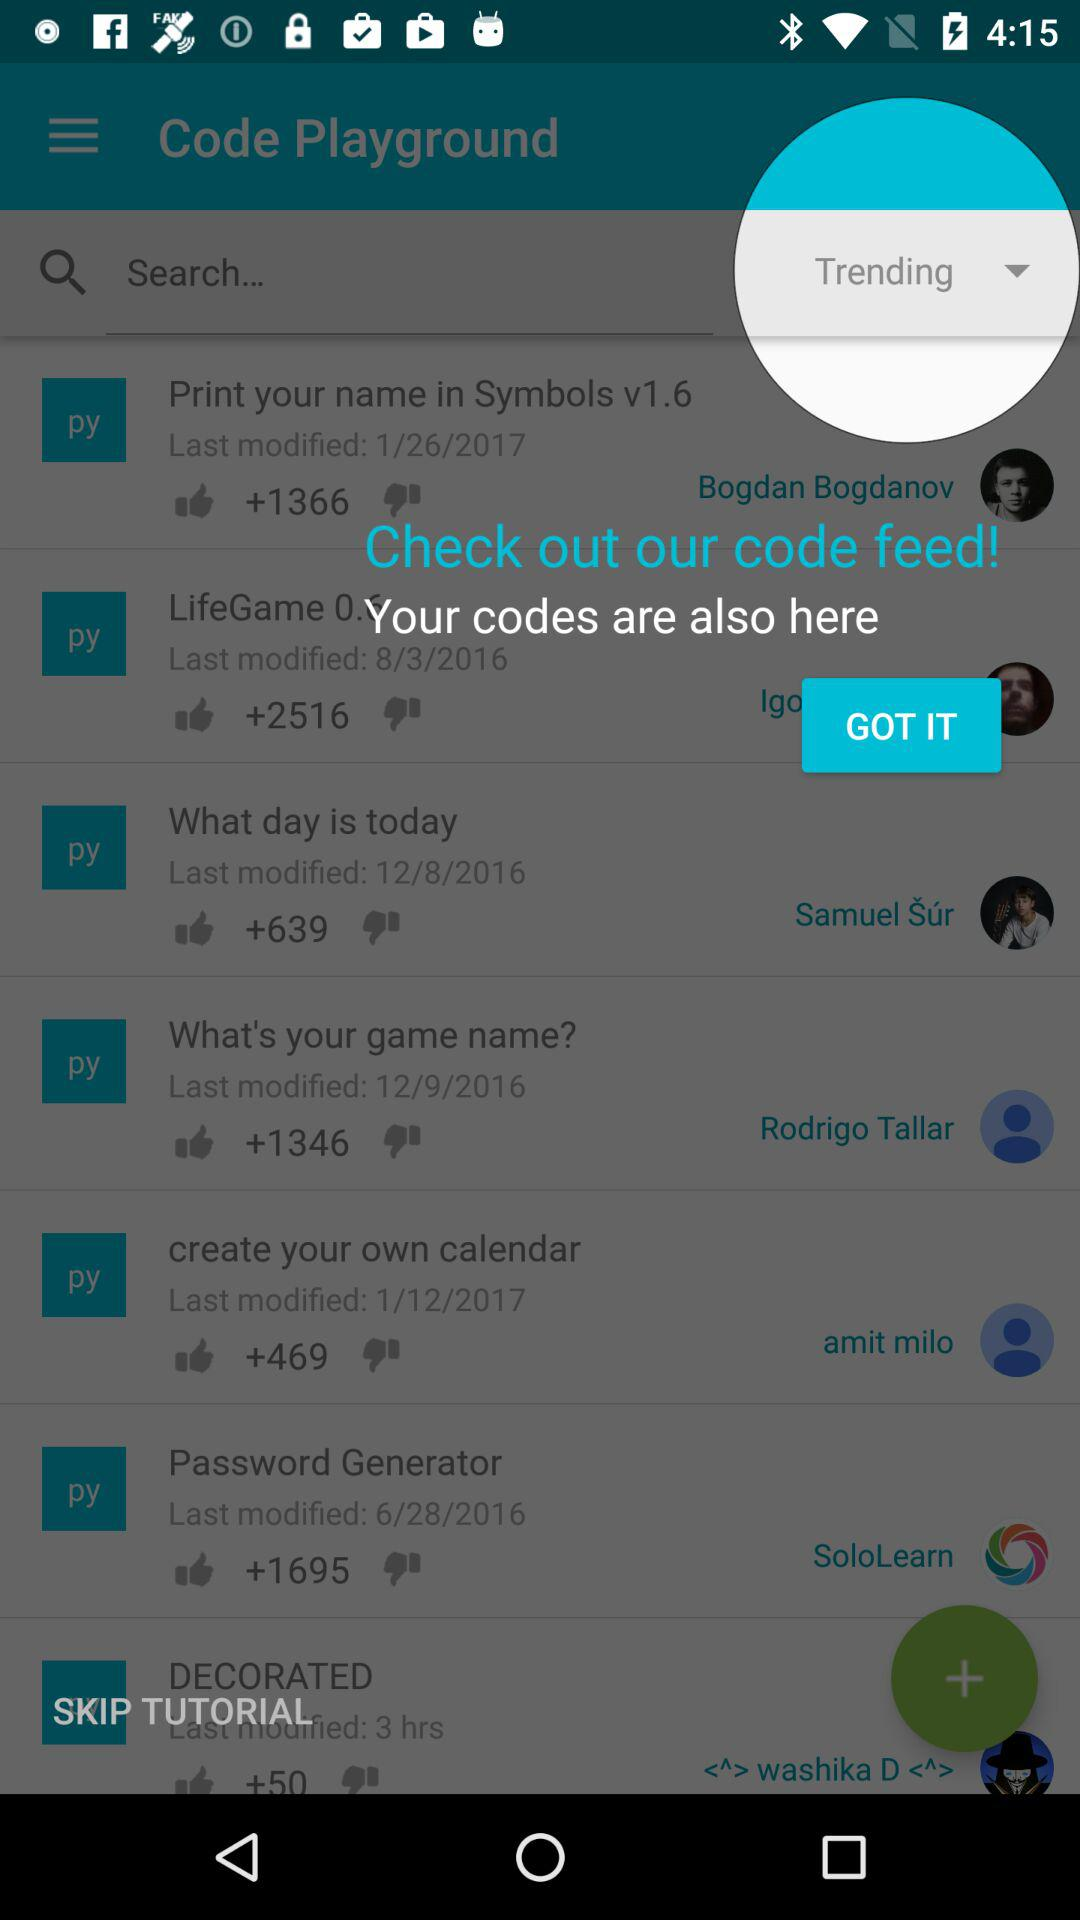How many items have a thumbs up of more than 1000?
Answer the question using a single word or phrase. 4 